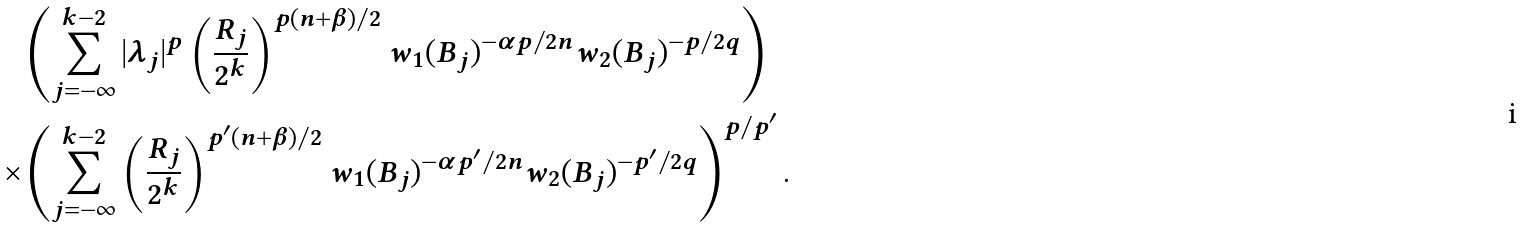<formula> <loc_0><loc_0><loc_500><loc_500>& \left ( \sum _ { j = - \infty } ^ { k - 2 } | \lambda _ { j } | ^ { p } \left ( \frac { R _ { j } } { 2 ^ { k } } \right ) ^ { p ( n + \beta ) / 2 } w _ { 1 } ( B _ { j } ) ^ { - { \alpha p } / { 2 n } } w _ { 2 } ( B _ { j } ) ^ { - p / { 2 q } } \right ) \\ \times & \left ( \sum _ { j = - \infty } ^ { k - 2 } \left ( \frac { R _ { j } } { 2 ^ { k } } \right ) ^ { p ^ { \prime } ( n + \beta ) / 2 } w _ { 1 } ( B _ { j } ) ^ { - { \alpha p ^ { \prime } } / { 2 n } } w _ { 2 } ( B _ { j } ) ^ { - p ^ { \prime } / { 2 q } } \right ) ^ { p / { p ^ { \prime } } } .</formula> 